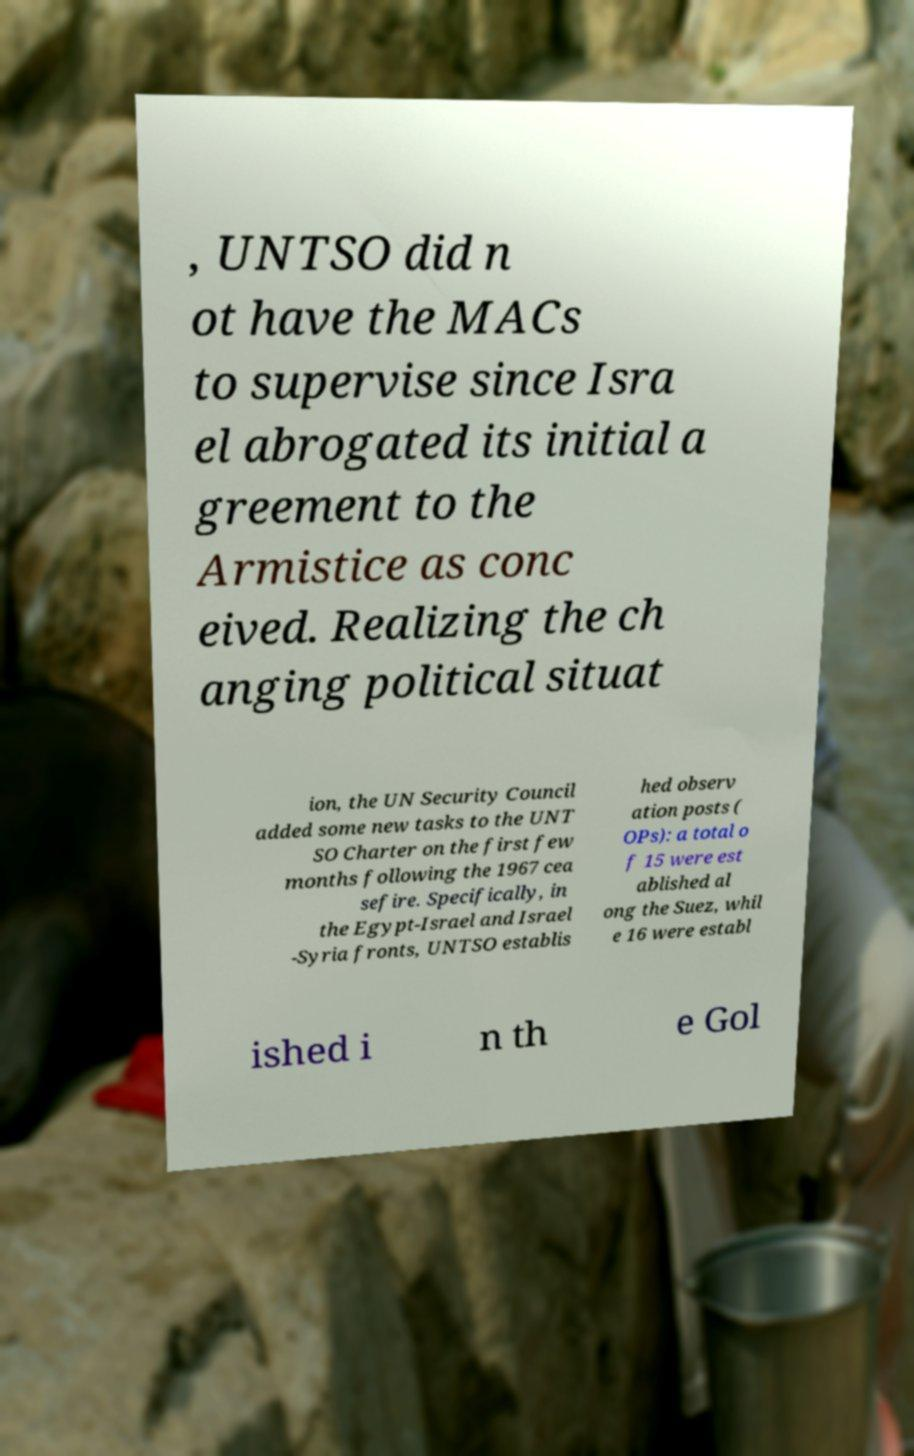I need the written content from this picture converted into text. Can you do that? , UNTSO did n ot have the MACs to supervise since Isra el abrogated its initial a greement to the Armistice as conc eived. Realizing the ch anging political situat ion, the UN Security Council added some new tasks to the UNT SO Charter on the first few months following the 1967 cea sefire. Specifically, in the Egypt-Israel and Israel -Syria fronts, UNTSO establis hed observ ation posts ( OPs): a total o f 15 were est ablished al ong the Suez, whil e 16 were establ ished i n th e Gol 